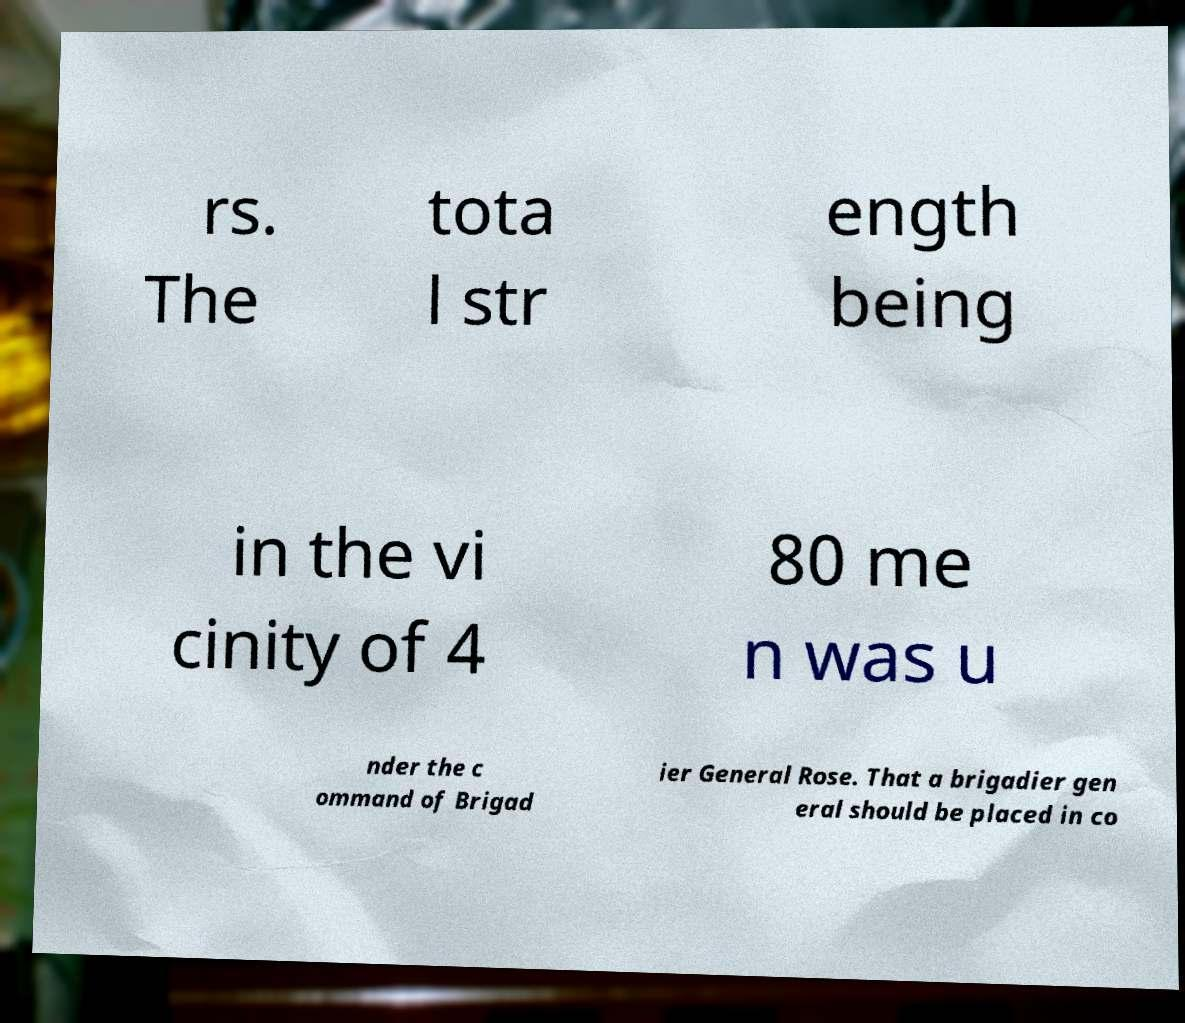For documentation purposes, I need the text within this image transcribed. Could you provide that? rs. The tota l str ength being in the vi cinity of 4 80 me n was u nder the c ommand of Brigad ier General Rose. That a brigadier gen eral should be placed in co 